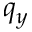<formula> <loc_0><loc_0><loc_500><loc_500>q _ { y }</formula> 